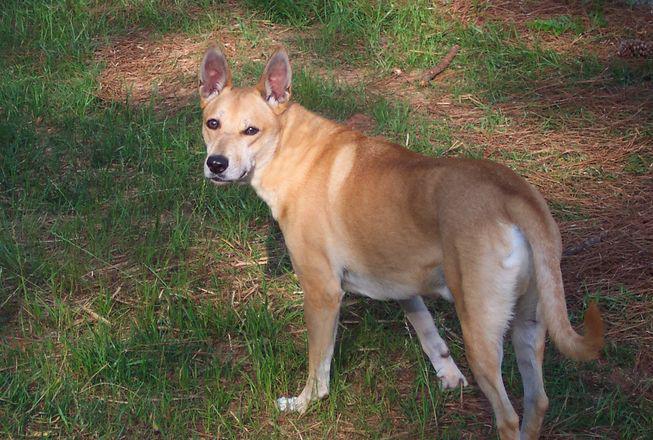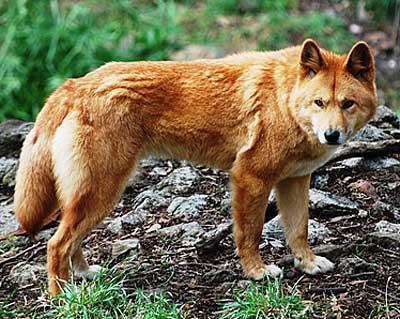The first image is the image on the left, the second image is the image on the right. Assess this claim about the two images: "In at least one image a lone dog on a red sand surface". Correct or not? Answer yes or no. No. The first image is the image on the left, the second image is the image on the right. For the images shown, is this caption "A dingo is walking on red dirt in one image." true? Answer yes or no. No. 